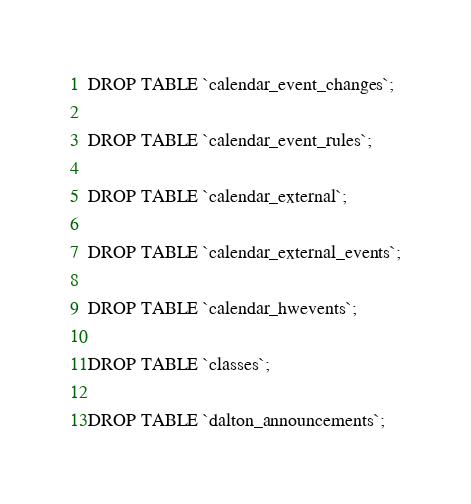Convert code to text. <code><loc_0><loc_0><loc_500><loc_500><_SQL_>DROP TABLE `calendar_event_changes`;

DROP TABLE `calendar_event_rules`;

DROP TABLE `calendar_external`;

DROP TABLE `calendar_external_events`;

DROP TABLE `calendar_hwevents`;

DROP TABLE `classes`;

DROP TABLE `dalton_announcements`;
</code> 